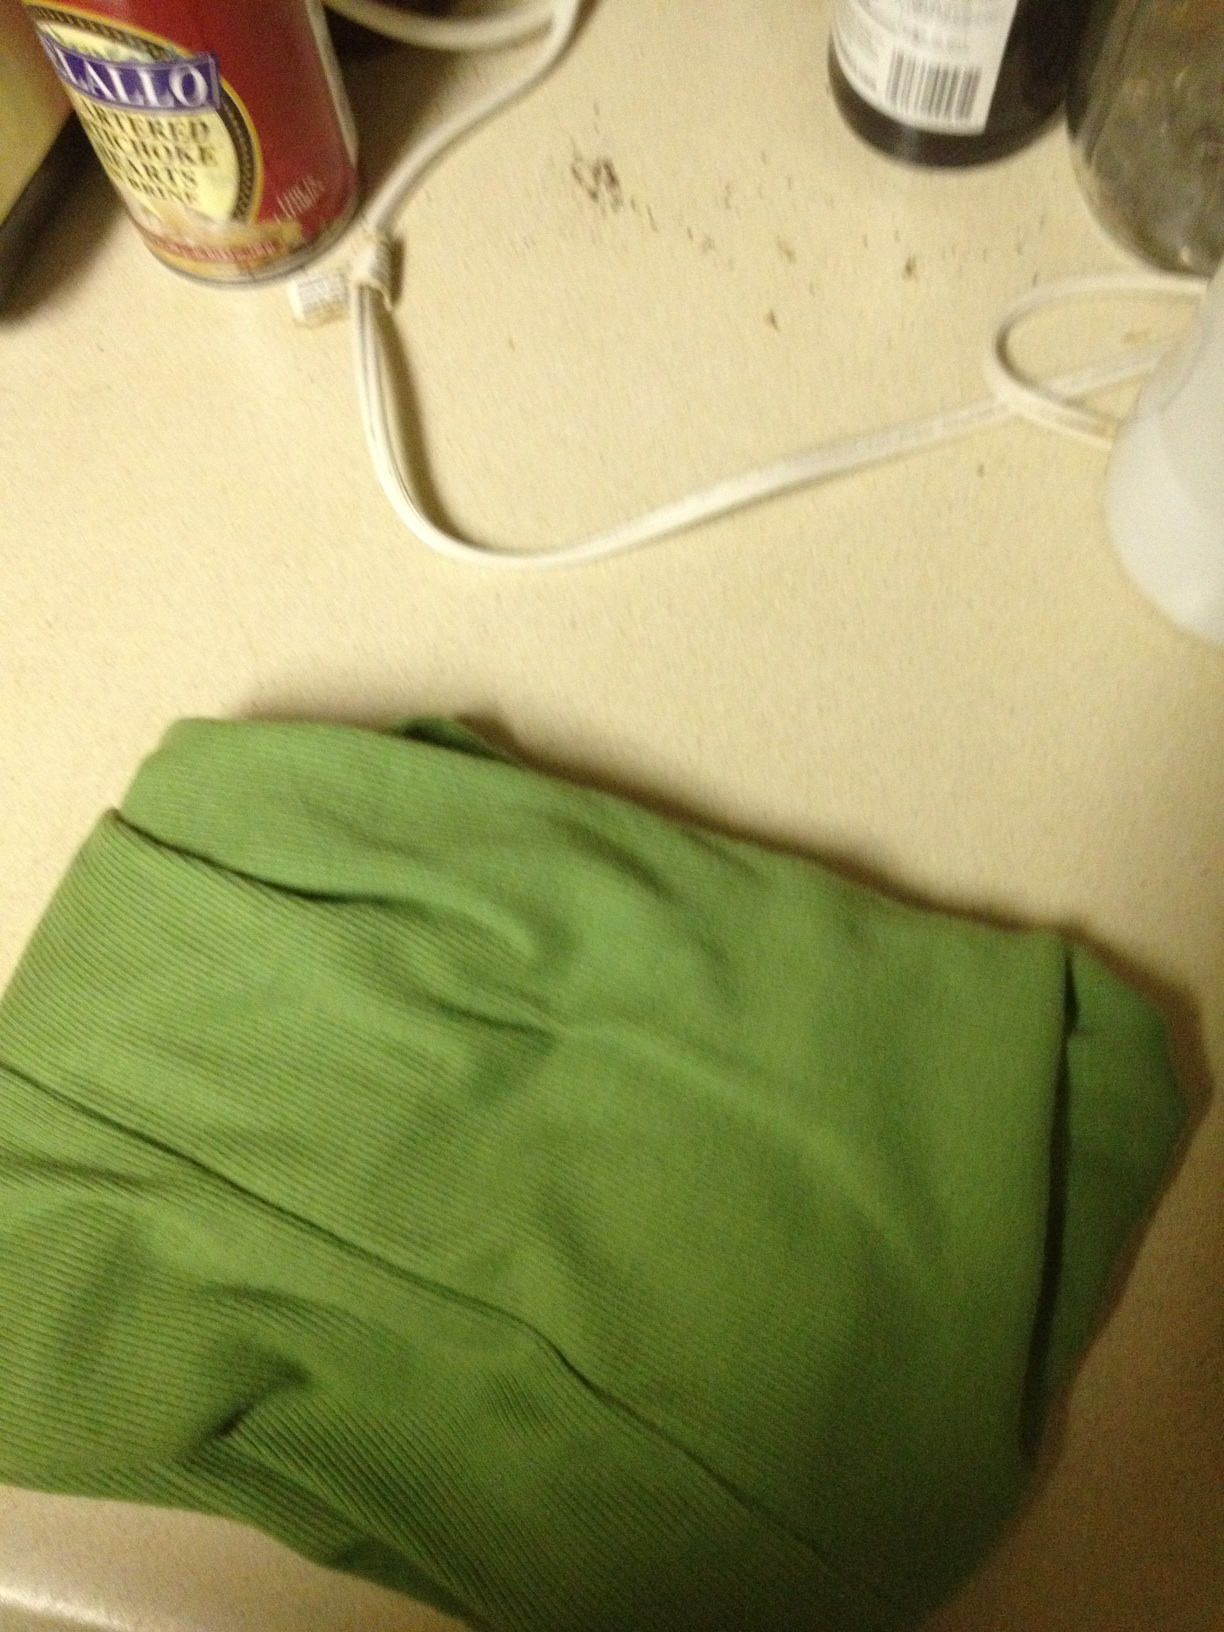Can you describe the color and material of the shirt? The shirt appears to be a vibrant green color and seems to be made of a soft, possibly cotton or knit material. Can this shirt be worn for formal occasions? Based on the appearance, this green shirt looks more casual and might be best suited for informal or semi-casual settings rather than formal occasions. 